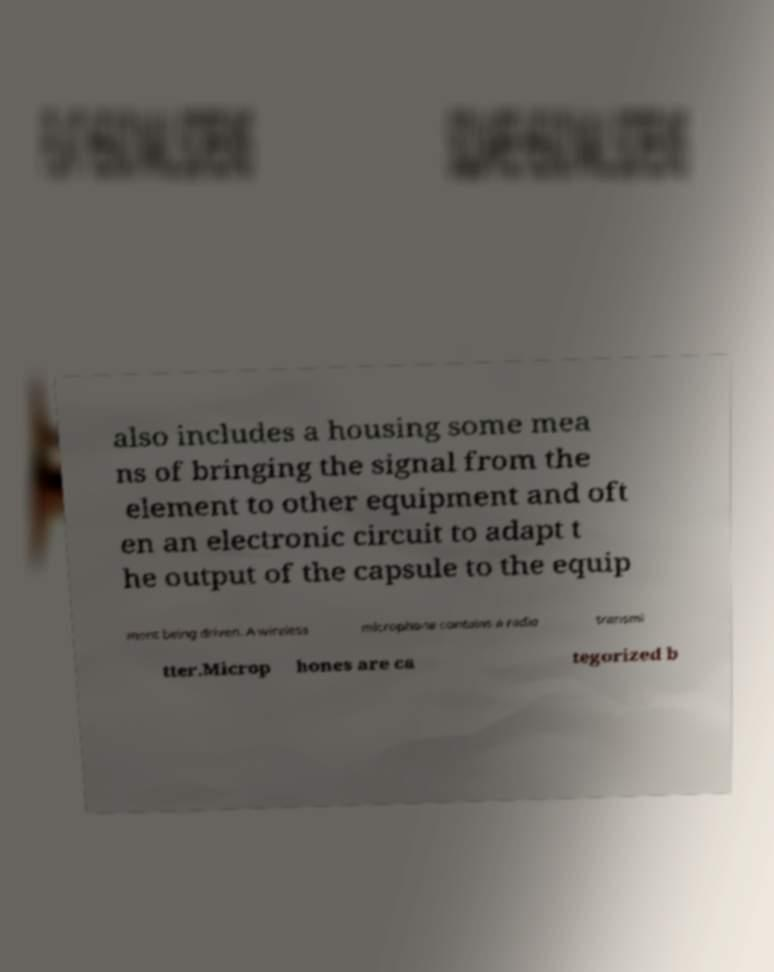Can you accurately transcribe the text from the provided image for me? also includes a housing some mea ns of bringing the signal from the element to other equipment and oft en an electronic circuit to adapt t he output of the capsule to the equip ment being driven. A wireless microphone contains a radio transmi tter.Microp hones are ca tegorized b 